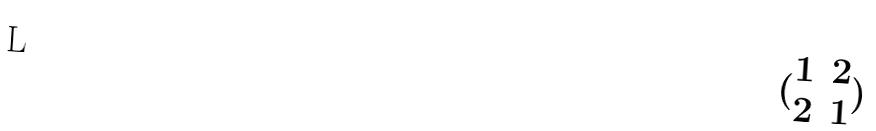Convert formula to latex. <formula><loc_0><loc_0><loc_500><loc_500>( \begin{matrix} 1 & 2 \\ 2 & 1 \end{matrix} )</formula> 